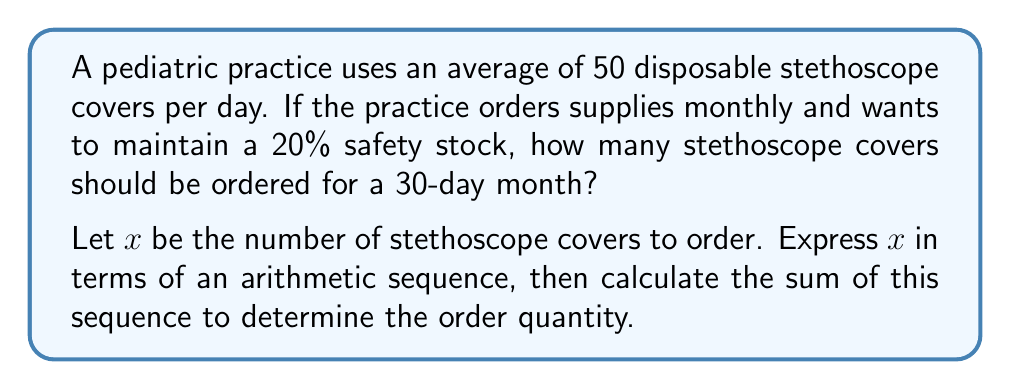Give your solution to this math problem. Let's approach this step-by-step:

1) First, we need to calculate the base number of stethoscope covers needed for 30 days:
   $50 \text{ covers/day} \times 30 \text{ days} = 1500 \text{ covers}$

2) Now, we need to add a 20% safety stock. To calculate this:
   $20\% \text{ of } 1500 = 0.20 \times 1500 = 300 \text{ covers}$

3) The total number of covers needed is:
   $1500 + 300 = 1800 \text{ covers}$

4) To express this as an arithmetic sequence, we can think of it as adding 60 covers per day (50 for use + 10 for safety stock) for 30 days:

   Let $a_n$ be the cumulative number of covers for day $n$. Then:
   $a_n = 60n$, where $n = 1, 2, 3, ..., 30$

5) The sum of this arithmetic sequence will give us the total number of covers:

   $$S_{30} = \frac{n(a_1 + a_{30})}{2} = \frac{30(60 + 60 \times 30)}{2}$$

6) Simplify:
   $$S_{30} = \frac{30(60 + 1800)}{2} = \frac{30 \times 1860}{2} = 27900$$

7) Therefore, $x = 1800$ covers should be ordered.
Answer: 1800 covers 